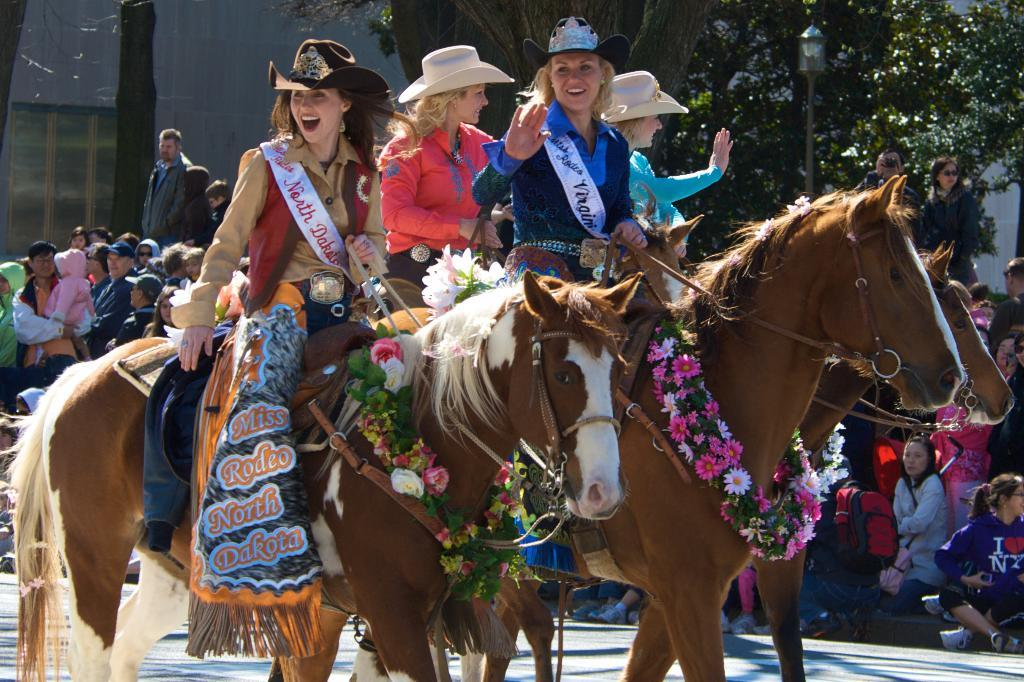Who or what can be seen in the image? There are people and horses in the image. What decorative element is present in the image? There is a garland in the image. What type of natural elements are visible in the image? There are trees in the image. What architectural feature is present in the image? There is a light pole in the image. What man-made structure is visible in the image? There is a window and a wall in the image. Can you describe any other objects in the image? There are unspecified objects in the image. What type of grass is growing on the sock in the image? There is no sock or grass present in the image. Can you tell me the statement made by the person in the image? There is no statement made by a person in the image; we can only observe the visual elements. 